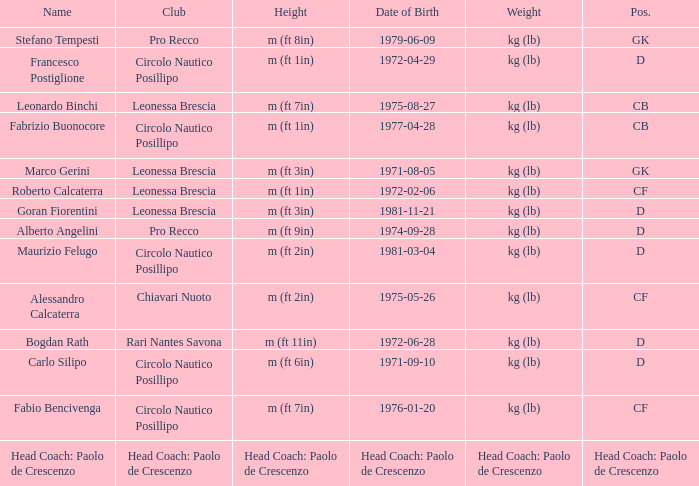What is the weight of the entry that has a date of birth of 1981-11-21? Kg (lb). 